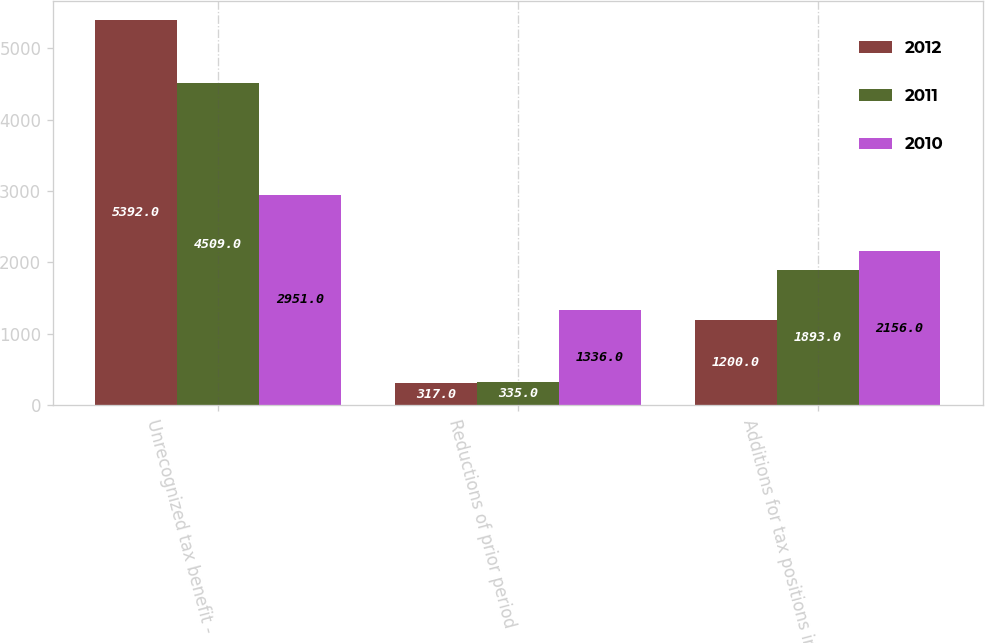Convert chart. <chart><loc_0><loc_0><loc_500><loc_500><stacked_bar_chart><ecel><fcel>Unrecognized tax benefit -<fcel>Reductions of prior period<fcel>Additions for tax positions in<nl><fcel>2012<fcel>5392<fcel>317<fcel>1200<nl><fcel>2011<fcel>4509<fcel>335<fcel>1893<nl><fcel>2010<fcel>2951<fcel>1336<fcel>2156<nl></chart> 